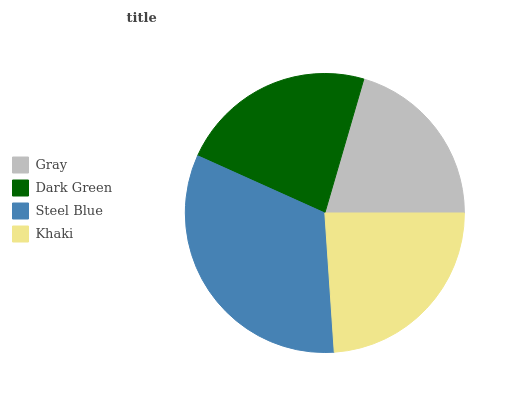Is Gray the minimum?
Answer yes or no. Yes. Is Steel Blue the maximum?
Answer yes or no. Yes. Is Dark Green the minimum?
Answer yes or no. No. Is Dark Green the maximum?
Answer yes or no. No. Is Dark Green greater than Gray?
Answer yes or no. Yes. Is Gray less than Dark Green?
Answer yes or no. Yes. Is Gray greater than Dark Green?
Answer yes or no. No. Is Dark Green less than Gray?
Answer yes or no. No. Is Khaki the high median?
Answer yes or no. Yes. Is Dark Green the low median?
Answer yes or no. Yes. Is Steel Blue the high median?
Answer yes or no. No. Is Gray the low median?
Answer yes or no. No. 